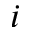Convert formula to latex. <formula><loc_0><loc_0><loc_500><loc_500>i</formula> 